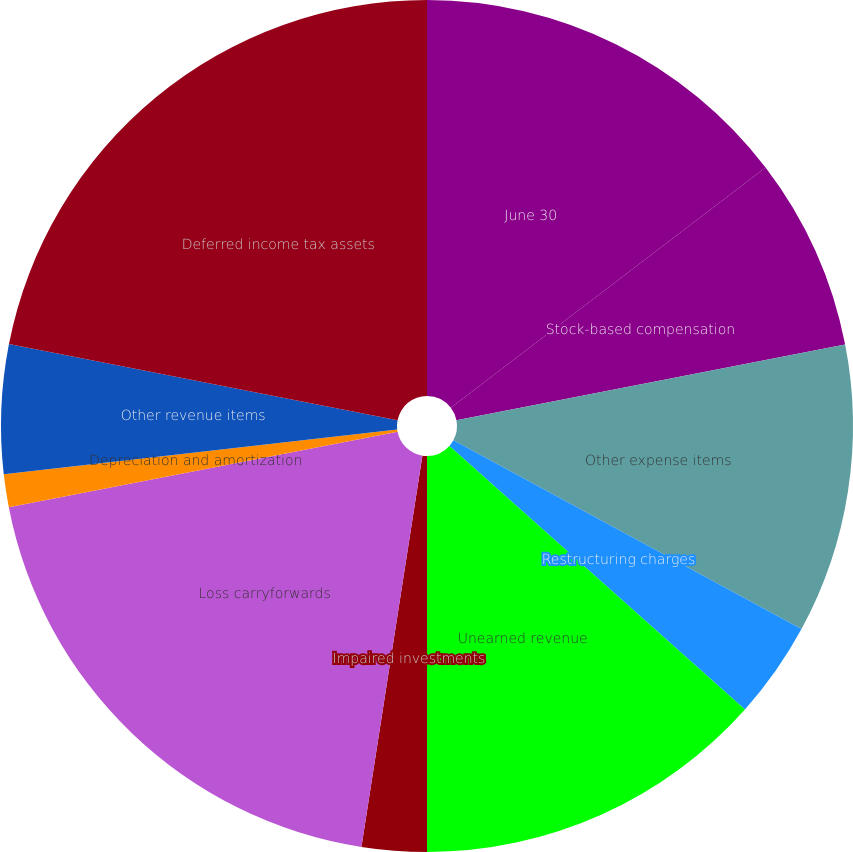<chart> <loc_0><loc_0><loc_500><loc_500><pie_chart><fcel>June 30<fcel>Stock-based compensation<fcel>Other expense items<fcel>Restructuring charges<fcel>Unearned revenue<fcel>Impaired investments<fcel>Loss carryforwards<fcel>Depreciation and amortization<fcel>Other revenue items<fcel>Deferred income tax assets<nl><fcel>14.62%<fcel>7.32%<fcel>10.97%<fcel>3.68%<fcel>13.41%<fcel>2.46%<fcel>19.49%<fcel>1.24%<fcel>4.89%<fcel>21.92%<nl></chart> 